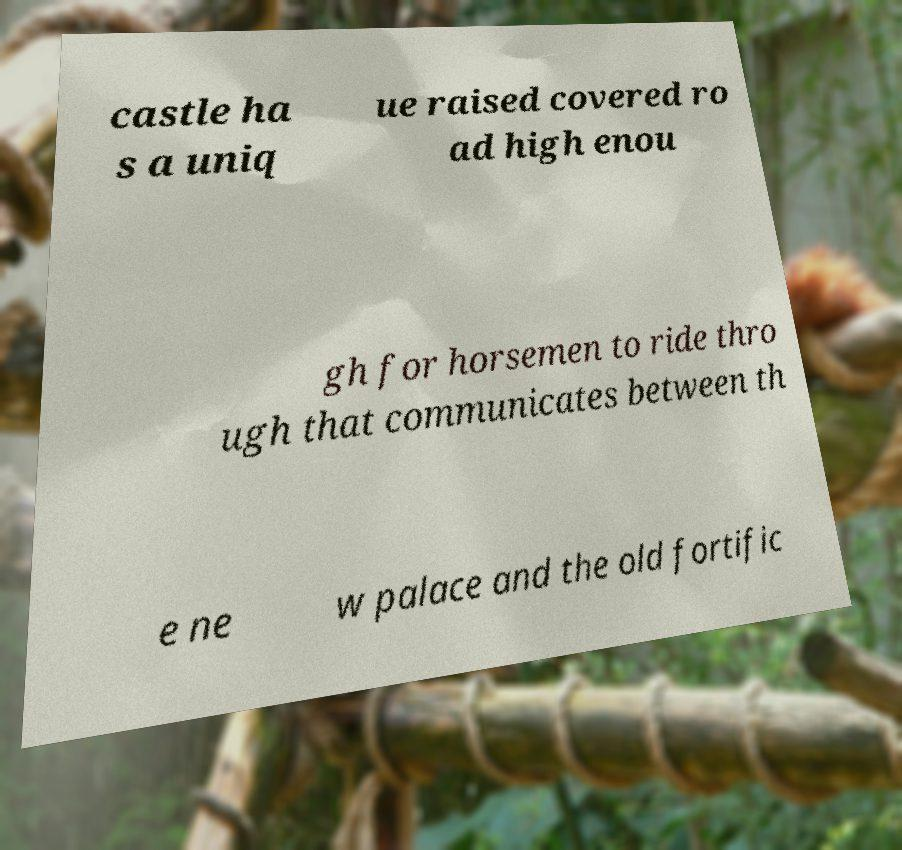Please identify and transcribe the text found in this image. castle ha s a uniq ue raised covered ro ad high enou gh for horsemen to ride thro ugh that communicates between th e ne w palace and the old fortific 